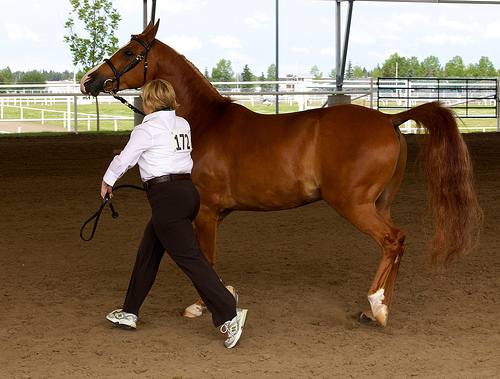<image>
Can you confirm if the jockey is to the left of the horse? Yes. From this viewpoint, the jockey is positioned to the left side relative to the horse. 